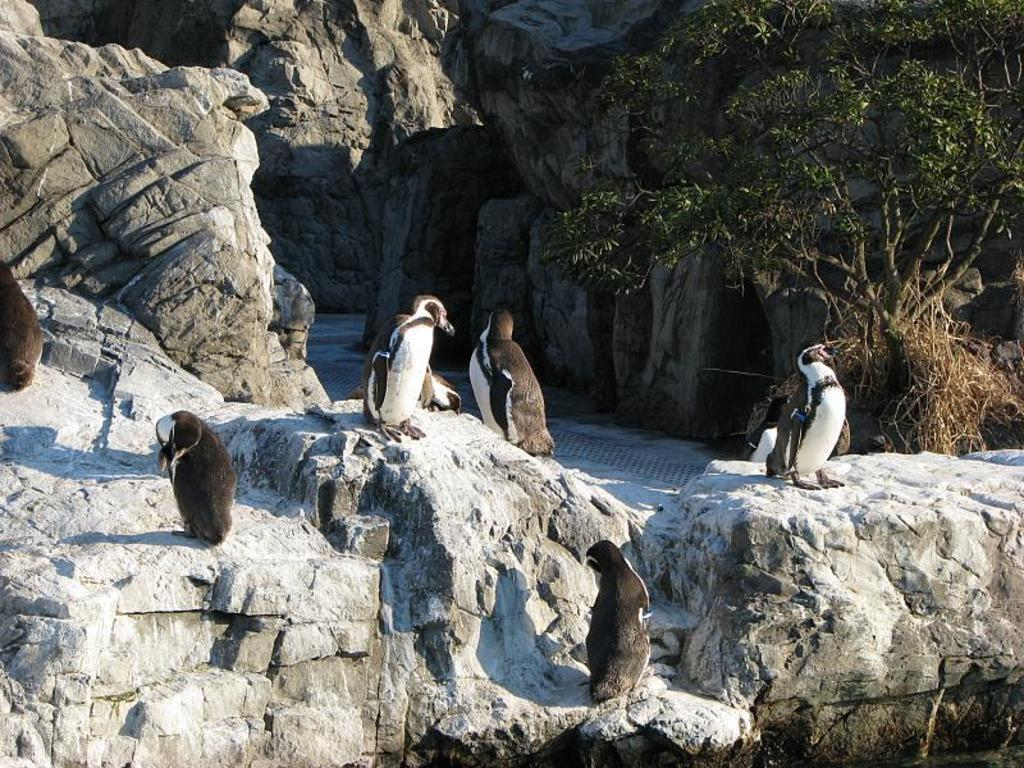What type of natural formation can be seen in the image? There are rocks in the image. What animals are present on the rocks? There are penguins on the rocks. What can be seen in the background of the image? There is a tree in the background of the image. What type of structure can be seen in the image? There is no structure present in the image; it features rocks, penguins, and a tree. What type of wound is visible on the penguins in the image? There are no visible wounds on the penguins in the image. 